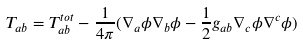<formula> <loc_0><loc_0><loc_500><loc_500>T _ { a b } = T _ { a b } ^ { t o t } - \frac { 1 } { 4 \pi } ( \nabla _ { a } \phi \nabla _ { b } \phi - \frac { 1 } { 2 } g _ { a b } \nabla _ { c } \phi \nabla ^ { c } \phi )</formula> 